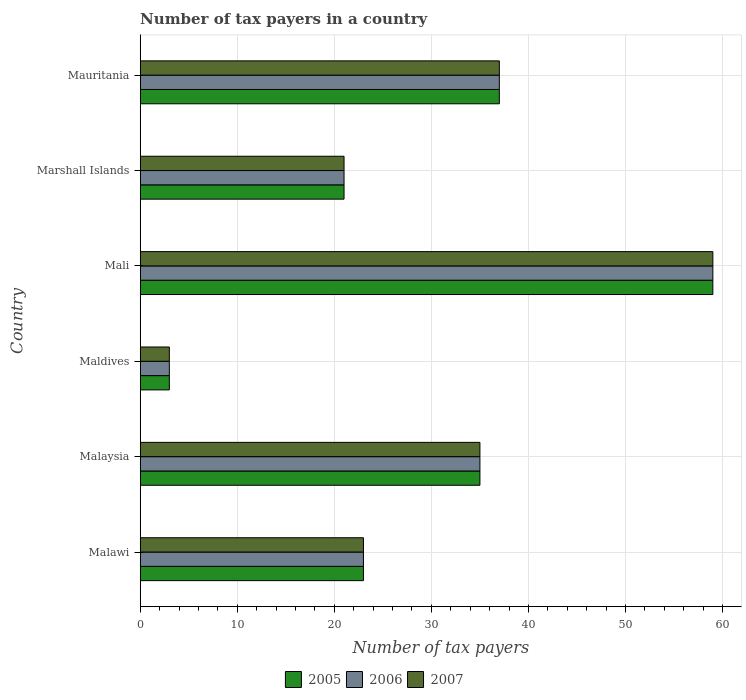Are the number of bars per tick equal to the number of legend labels?
Your response must be concise. Yes. How many bars are there on the 2nd tick from the bottom?
Offer a terse response. 3. What is the label of the 5th group of bars from the top?
Give a very brief answer. Malaysia. In how many cases, is the number of bars for a given country not equal to the number of legend labels?
Your answer should be compact. 0. Across all countries, what is the maximum number of tax payers in in 2006?
Make the answer very short. 59. Across all countries, what is the minimum number of tax payers in in 2007?
Your response must be concise. 3. In which country was the number of tax payers in in 2007 maximum?
Give a very brief answer. Mali. In which country was the number of tax payers in in 2007 minimum?
Make the answer very short. Maldives. What is the total number of tax payers in in 2006 in the graph?
Offer a very short reply. 178. What is the difference between the number of tax payers in in 2007 in Maldives and that in Marshall Islands?
Offer a terse response. -18. What is the average number of tax payers in in 2007 per country?
Your answer should be very brief. 29.67. In how many countries, is the number of tax payers in in 2007 greater than 46 ?
Your answer should be very brief. 1. What is the ratio of the number of tax payers in in 2005 in Marshall Islands to that in Mauritania?
Offer a terse response. 0.57. Is the number of tax payers in in 2005 in Malawi less than that in Marshall Islands?
Your response must be concise. No. What is the difference between the highest and the second highest number of tax payers in in 2005?
Your response must be concise. 22. What is the difference between the highest and the lowest number of tax payers in in 2007?
Keep it short and to the point. 56. Is the sum of the number of tax payers in in 2007 in Marshall Islands and Mauritania greater than the maximum number of tax payers in in 2005 across all countries?
Your response must be concise. No. Is it the case that in every country, the sum of the number of tax payers in in 2006 and number of tax payers in in 2005 is greater than the number of tax payers in in 2007?
Provide a succinct answer. Yes. How many bars are there?
Make the answer very short. 18. What is the difference between two consecutive major ticks on the X-axis?
Your answer should be very brief. 10. Are the values on the major ticks of X-axis written in scientific E-notation?
Ensure brevity in your answer.  No. Does the graph contain any zero values?
Offer a terse response. No. Does the graph contain grids?
Your answer should be very brief. Yes. How are the legend labels stacked?
Ensure brevity in your answer.  Horizontal. What is the title of the graph?
Your response must be concise. Number of tax payers in a country. Does "1973" appear as one of the legend labels in the graph?
Ensure brevity in your answer.  No. What is the label or title of the X-axis?
Provide a succinct answer. Number of tax payers. What is the label or title of the Y-axis?
Your answer should be very brief. Country. What is the Number of tax payers in 2006 in Malawi?
Offer a very short reply. 23. What is the Number of tax payers in 2005 in Malaysia?
Make the answer very short. 35. What is the Number of tax payers of 2006 in Malaysia?
Offer a very short reply. 35. What is the Number of tax payers of 2005 in Maldives?
Keep it short and to the point. 3. What is the Number of tax payers in 2006 in Maldives?
Ensure brevity in your answer.  3. What is the Number of tax payers in 2005 in Mali?
Your answer should be compact. 59. What is the Number of tax payers in 2005 in Marshall Islands?
Offer a terse response. 21. What is the Number of tax payers of 2006 in Marshall Islands?
Your answer should be compact. 21. What is the Number of tax payers of 2007 in Marshall Islands?
Your response must be concise. 21. Across all countries, what is the maximum Number of tax payers of 2005?
Keep it short and to the point. 59. Across all countries, what is the maximum Number of tax payers of 2006?
Ensure brevity in your answer.  59. Across all countries, what is the maximum Number of tax payers of 2007?
Your response must be concise. 59. Across all countries, what is the minimum Number of tax payers of 2005?
Make the answer very short. 3. Across all countries, what is the minimum Number of tax payers of 2006?
Offer a very short reply. 3. What is the total Number of tax payers in 2005 in the graph?
Offer a terse response. 178. What is the total Number of tax payers in 2006 in the graph?
Keep it short and to the point. 178. What is the total Number of tax payers in 2007 in the graph?
Keep it short and to the point. 178. What is the difference between the Number of tax payers in 2006 in Malawi and that in Malaysia?
Keep it short and to the point. -12. What is the difference between the Number of tax payers in 2007 in Malawi and that in Malaysia?
Keep it short and to the point. -12. What is the difference between the Number of tax payers of 2005 in Malawi and that in Maldives?
Your response must be concise. 20. What is the difference between the Number of tax payers of 2006 in Malawi and that in Maldives?
Ensure brevity in your answer.  20. What is the difference between the Number of tax payers of 2005 in Malawi and that in Mali?
Your answer should be compact. -36. What is the difference between the Number of tax payers of 2006 in Malawi and that in Mali?
Provide a short and direct response. -36. What is the difference between the Number of tax payers of 2007 in Malawi and that in Mali?
Ensure brevity in your answer.  -36. What is the difference between the Number of tax payers of 2005 in Malawi and that in Marshall Islands?
Make the answer very short. 2. What is the difference between the Number of tax payers of 2007 in Malawi and that in Marshall Islands?
Your response must be concise. 2. What is the difference between the Number of tax payers of 2006 in Malawi and that in Mauritania?
Your answer should be very brief. -14. What is the difference between the Number of tax payers of 2006 in Malaysia and that in Maldives?
Ensure brevity in your answer.  32. What is the difference between the Number of tax payers in 2007 in Malaysia and that in Maldives?
Give a very brief answer. 32. What is the difference between the Number of tax payers of 2005 in Malaysia and that in Mali?
Your answer should be compact. -24. What is the difference between the Number of tax payers of 2006 in Malaysia and that in Mali?
Ensure brevity in your answer.  -24. What is the difference between the Number of tax payers of 2007 in Malaysia and that in Mali?
Offer a terse response. -24. What is the difference between the Number of tax payers of 2005 in Malaysia and that in Marshall Islands?
Provide a succinct answer. 14. What is the difference between the Number of tax payers of 2007 in Malaysia and that in Marshall Islands?
Keep it short and to the point. 14. What is the difference between the Number of tax payers of 2005 in Malaysia and that in Mauritania?
Ensure brevity in your answer.  -2. What is the difference between the Number of tax payers in 2006 in Malaysia and that in Mauritania?
Offer a very short reply. -2. What is the difference between the Number of tax payers of 2007 in Malaysia and that in Mauritania?
Give a very brief answer. -2. What is the difference between the Number of tax payers in 2005 in Maldives and that in Mali?
Offer a terse response. -56. What is the difference between the Number of tax payers of 2006 in Maldives and that in Mali?
Your response must be concise. -56. What is the difference between the Number of tax payers of 2007 in Maldives and that in Mali?
Your answer should be very brief. -56. What is the difference between the Number of tax payers of 2005 in Maldives and that in Marshall Islands?
Your answer should be very brief. -18. What is the difference between the Number of tax payers in 2006 in Maldives and that in Marshall Islands?
Offer a very short reply. -18. What is the difference between the Number of tax payers of 2005 in Maldives and that in Mauritania?
Offer a terse response. -34. What is the difference between the Number of tax payers of 2006 in Maldives and that in Mauritania?
Offer a very short reply. -34. What is the difference between the Number of tax payers of 2007 in Maldives and that in Mauritania?
Offer a terse response. -34. What is the difference between the Number of tax payers of 2007 in Mali and that in Marshall Islands?
Provide a short and direct response. 38. What is the difference between the Number of tax payers of 2005 in Mali and that in Mauritania?
Offer a very short reply. 22. What is the difference between the Number of tax payers of 2006 in Mali and that in Mauritania?
Give a very brief answer. 22. What is the difference between the Number of tax payers of 2005 in Marshall Islands and that in Mauritania?
Your answer should be very brief. -16. What is the difference between the Number of tax payers in 2006 in Marshall Islands and that in Mauritania?
Keep it short and to the point. -16. What is the difference between the Number of tax payers in 2007 in Marshall Islands and that in Mauritania?
Ensure brevity in your answer.  -16. What is the difference between the Number of tax payers in 2005 in Malawi and the Number of tax payers in 2006 in Maldives?
Keep it short and to the point. 20. What is the difference between the Number of tax payers in 2005 in Malawi and the Number of tax payers in 2007 in Maldives?
Offer a very short reply. 20. What is the difference between the Number of tax payers of 2005 in Malawi and the Number of tax payers of 2006 in Mali?
Keep it short and to the point. -36. What is the difference between the Number of tax payers of 2005 in Malawi and the Number of tax payers of 2007 in Mali?
Your answer should be very brief. -36. What is the difference between the Number of tax payers in 2006 in Malawi and the Number of tax payers in 2007 in Mali?
Offer a terse response. -36. What is the difference between the Number of tax payers in 2005 in Malawi and the Number of tax payers in 2007 in Marshall Islands?
Offer a very short reply. 2. What is the difference between the Number of tax payers in 2006 in Malawi and the Number of tax payers in 2007 in Marshall Islands?
Offer a very short reply. 2. What is the difference between the Number of tax payers of 2005 in Malawi and the Number of tax payers of 2007 in Mauritania?
Ensure brevity in your answer.  -14. What is the difference between the Number of tax payers of 2006 in Malawi and the Number of tax payers of 2007 in Mauritania?
Give a very brief answer. -14. What is the difference between the Number of tax payers of 2005 in Malaysia and the Number of tax payers of 2006 in Maldives?
Offer a terse response. 32. What is the difference between the Number of tax payers of 2005 in Malaysia and the Number of tax payers of 2007 in Mali?
Give a very brief answer. -24. What is the difference between the Number of tax payers in 2006 in Malaysia and the Number of tax payers in 2007 in Mali?
Keep it short and to the point. -24. What is the difference between the Number of tax payers of 2005 in Malaysia and the Number of tax payers of 2007 in Marshall Islands?
Your answer should be very brief. 14. What is the difference between the Number of tax payers of 2006 in Malaysia and the Number of tax payers of 2007 in Marshall Islands?
Your answer should be very brief. 14. What is the difference between the Number of tax payers of 2005 in Malaysia and the Number of tax payers of 2007 in Mauritania?
Offer a very short reply. -2. What is the difference between the Number of tax payers of 2006 in Malaysia and the Number of tax payers of 2007 in Mauritania?
Keep it short and to the point. -2. What is the difference between the Number of tax payers in 2005 in Maldives and the Number of tax payers in 2006 in Mali?
Your answer should be very brief. -56. What is the difference between the Number of tax payers in 2005 in Maldives and the Number of tax payers in 2007 in Mali?
Give a very brief answer. -56. What is the difference between the Number of tax payers of 2006 in Maldives and the Number of tax payers of 2007 in Mali?
Keep it short and to the point. -56. What is the difference between the Number of tax payers of 2005 in Maldives and the Number of tax payers of 2006 in Marshall Islands?
Your response must be concise. -18. What is the difference between the Number of tax payers of 2005 in Maldives and the Number of tax payers of 2007 in Marshall Islands?
Ensure brevity in your answer.  -18. What is the difference between the Number of tax payers in 2006 in Maldives and the Number of tax payers in 2007 in Marshall Islands?
Keep it short and to the point. -18. What is the difference between the Number of tax payers of 2005 in Maldives and the Number of tax payers of 2006 in Mauritania?
Provide a short and direct response. -34. What is the difference between the Number of tax payers of 2005 in Maldives and the Number of tax payers of 2007 in Mauritania?
Make the answer very short. -34. What is the difference between the Number of tax payers of 2006 in Maldives and the Number of tax payers of 2007 in Mauritania?
Provide a succinct answer. -34. What is the difference between the Number of tax payers of 2005 in Mali and the Number of tax payers of 2007 in Marshall Islands?
Your answer should be compact. 38. What is the difference between the Number of tax payers of 2006 in Mali and the Number of tax payers of 2007 in Mauritania?
Your response must be concise. 22. What is the difference between the Number of tax payers of 2005 in Marshall Islands and the Number of tax payers of 2006 in Mauritania?
Your answer should be very brief. -16. What is the average Number of tax payers in 2005 per country?
Ensure brevity in your answer.  29.67. What is the average Number of tax payers of 2006 per country?
Give a very brief answer. 29.67. What is the average Number of tax payers of 2007 per country?
Offer a very short reply. 29.67. What is the difference between the Number of tax payers in 2005 and Number of tax payers in 2007 in Malawi?
Your response must be concise. 0. What is the difference between the Number of tax payers of 2006 and Number of tax payers of 2007 in Malawi?
Offer a terse response. 0. What is the difference between the Number of tax payers of 2005 and Number of tax payers of 2006 in Malaysia?
Keep it short and to the point. 0. What is the difference between the Number of tax payers in 2005 and Number of tax payers in 2007 in Malaysia?
Make the answer very short. 0. What is the difference between the Number of tax payers of 2005 and Number of tax payers of 2007 in Marshall Islands?
Offer a terse response. 0. What is the difference between the Number of tax payers in 2005 and Number of tax payers in 2006 in Mauritania?
Offer a very short reply. 0. What is the difference between the Number of tax payers in 2005 and Number of tax payers in 2007 in Mauritania?
Offer a terse response. 0. What is the difference between the Number of tax payers of 2006 and Number of tax payers of 2007 in Mauritania?
Provide a short and direct response. 0. What is the ratio of the Number of tax payers in 2005 in Malawi to that in Malaysia?
Provide a short and direct response. 0.66. What is the ratio of the Number of tax payers in 2006 in Malawi to that in Malaysia?
Give a very brief answer. 0.66. What is the ratio of the Number of tax payers in 2007 in Malawi to that in Malaysia?
Provide a succinct answer. 0.66. What is the ratio of the Number of tax payers of 2005 in Malawi to that in Maldives?
Give a very brief answer. 7.67. What is the ratio of the Number of tax payers of 2006 in Malawi to that in Maldives?
Provide a short and direct response. 7.67. What is the ratio of the Number of tax payers of 2007 in Malawi to that in Maldives?
Offer a very short reply. 7.67. What is the ratio of the Number of tax payers in 2005 in Malawi to that in Mali?
Offer a terse response. 0.39. What is the ratio of the Number of tax payers of 2006 in Malawi to that in Mali?
Offer a very short reply. 0.39. What is the ratio of the Number of tax payers in 2007 in Malawi to that in Mali?
Ensure brevity in your answer.  0.39. What is the ratio of the Number of tax payers of 2005 in Malawi to that in Marshall Islands?
Give a very brief answer. 1.1. What is the ratio of the Number of tax payers in 2006 in Malawi to that in Marshall Islands?
Your answer should be compact. 1.1. What is the ratio of the Number of tax payers in 2007 in Malawi to that in Marshall Islands?
Offer a terse response. 1.1. What is the ratio of the Number of tax payers in 2005 in Malawi to that in Mauritania?
Provide a short and direct response. 0.62. What is the ratio of the Number of tax payers of 2006 in Malawi to that in Mauritania?
Offer a terse response. 0.62. What is the ratio of the Number of tax payers in 2007 in Malawi to that in Mauritania?
Keep it short and to the point. 0.62. What is the ratio of the Number of tax payers of 2005 in Malaysia to that in Maldives?
Your answer should be compact. 11.67. What is the ratio of the Number of tax payers of 2006 in Malaysia to that in Maldives?
Ensure brevity in your answer.  11.67. What is the ratio of the Number of tax payers of 2007 in Malaysia to that in Maldives?
Provide a succinct answer. 11.67. What is the ratio of the Number of tax payers of 2005 in Malaysia to that in Mali?
Make the answer very short. 0.59. What is the ratio of the Number of tax payers of 2006 in Malaysia to that in Mali?
Provide a short and direct response. 0.59. What is the ratio of the Number of tax payers in 2007 in Malaysia to that in Mali?
Your answer should be compact. 0.59. What is the ratio of the Number of tax payers of 2005 in Malaysia to that in Marshall Islands?
Provide a short and direct response. 1.67. What is the ratio of the Number of tax payers in 2006 in Malaysia to that in Marshall Islands?
Offer a terse response. 1.67. What is the ratio of the Number of tax payers of 2005 in Malaysia to that in Mauritania?
Your response must be concise. 0.95. What is the ratio of the Number of tax payers of 2006 in Malaysia to that in Mauritania?
Give a very brief answer. 0.95. What is the ratio of the Number of tax payers of 2007 in Malaysia to that in Mauritania?
Your response must be concise. 0.95. What is the ratio of the Number of tax payers of 2005 in Maldives to that in Mali?
Provide a succinct answer. 0.05. What is the ratio of the Number of tax payers of 2006 in Maldives to that in Mali?
Keep it short and to the point. 0.05. What is the ratio of the Number of tax payers of 2007 in Maldives to that in Mali?
Keep it short and to the point. 0.05. What is the ratio of the Number of tax payers of 2005 in Maldives to that in Marshall Islands?
Make the answer very short. 0.14. What is the ratio of the Number of tax payers of 2006 in Maldives to that in Marshall Islands?
Keep it short and to the point. 0.14. What is the ratio of the Number of tax payers in 2007 in Maldives to that in Marshall Islands?
Offer a terse response. 0.14. What is the ratio of the Number of tax payers of 2005 in Maldives to that in Mauritania?
Your answer should be compact. 0.08. What is the ratio of the Number of tax payers in 2006 in Maldives to that in Mauritania?
Your response must be concise. 0.08. What is the ratio of the Number of tax payers of 2007 in Maldives to that in Mauritania?
Offer a terse response. 0.08. What is the ratio of the Number of tax payers of 2005 in Mali to that in Marshall Islands?
Keep it short and to the point. 2.81. What is the ratio of the Number of tax payers of 2006 in Mali to that in Marshall Islands?
Offer a very short reply. 2.81. What is the ratio of the Number of tax payers of 2007 in Mali to that in Marshall Islands?
Your answer should be very brief. 2.81. What is the ratio of the Number of tax payers of 2005 in Mali to that in Mauritania?
Give a very brief answer. 1.59. What is the ratio of the Number of tax payers of 2006 in Mali to that in Mauritania?
Ensure brevity in your answer.  1.59. What is the ratio of the Number of tax payers of 2007 in Mali to that in Mauritania?
Provide a succinct answer. 1.59. What is the ratio of the Number of tax payers in 2005 in Marshall Islands to that in Mauritania?
Give a very brief answer. 0.57. What is the ratio of the Number of tax payers in 2006 in Marshall Islands to that in Mauritania?
Ensure brevity in your answer.  0.57. What is the ratio of the Number of tax payers of 2007 in Marshall Islands to that in Mauritania?
Ensure brevity in your answer.  0.57. What is the difference between the highest and the second highest Number of tax payers of 2005?
Give a very brief answer. 22. What is the difference between the highest and the second highest Number of tax payers in 2006?
Ensure brevity in your answer.  22. What is the difference between the highest and the lowest Number of tax payers of 2006?
Make the answer very short. 56. What is the difference between the highest and the lowest Number of tax payers of 2007?
Your answer should be very brief. 56. 